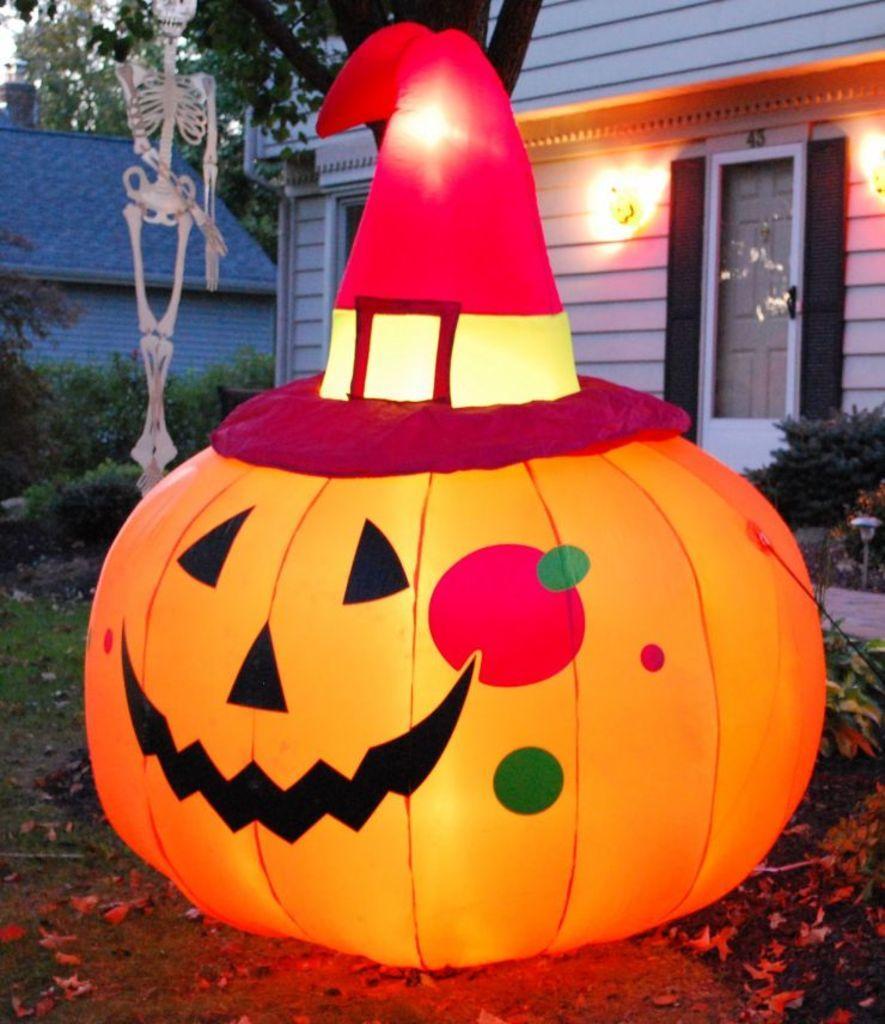Can you describe this image briefly? In the center of the image we can see a pumpkin decor. In the background there is a shed, trees, board and bushes. 